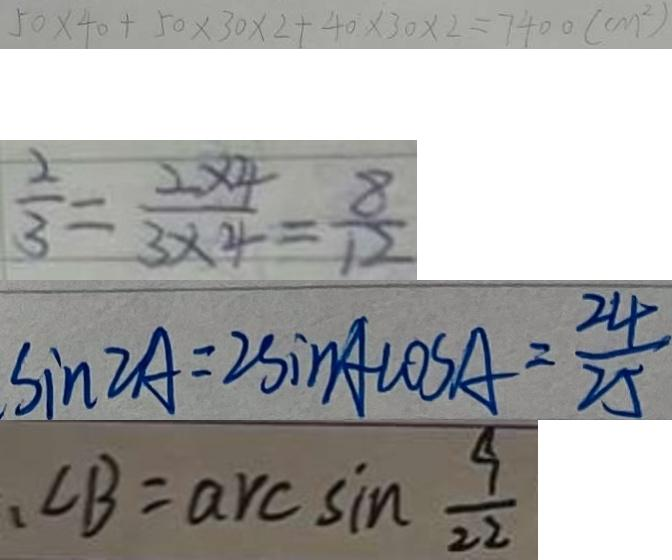<formula> <loc_0><loc_0><loc_500><loc_500>5 0 \times 4 0 + 5 0 \times 3 0 \times 2 + 4 0 \times 3 0 \times 2 = 7 4 0 0 ( c m ^ { 2 } ) 
 \frac { 2 } { 3 } = \frac { 2 \times 4 } { 3 \times 4 } = \frac { 8 } { 1 2 } 
 \sin 2 A = 2 \sin A \cos A = \frac { 2 4 } { 2 5 } 
 、 \angle B = \arcsin \frac { 9 } { 2 2 }</formula> 